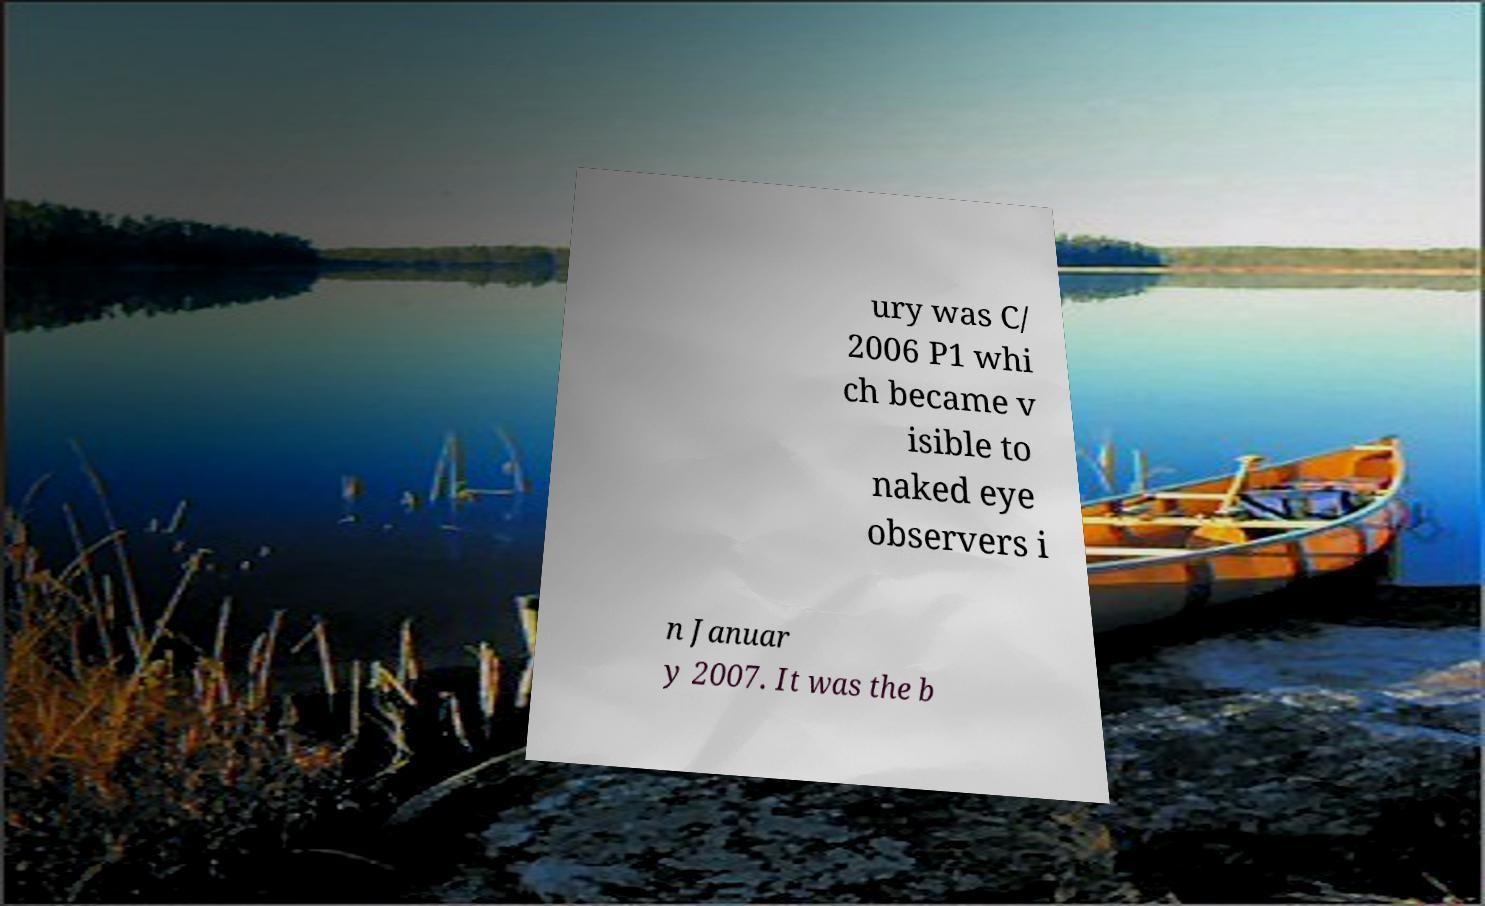Could you assist in decoding the text presented in this image and type it out clearly? ury was C/ 2006 P1 whi ch became v isible to naked eye observers i n Januar y 2007. It was the b 